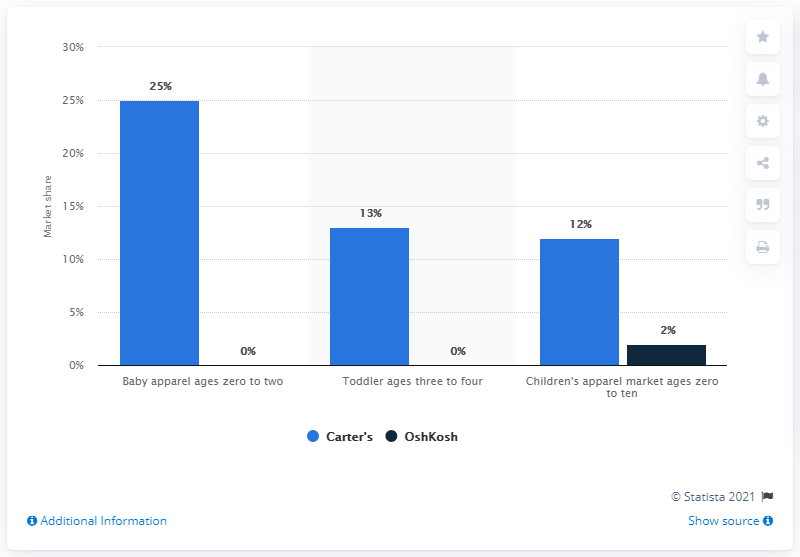Add Carter's percentage in Toddler ages three to four and children's apparel market ages zero to ten and subtract it with Carter's baby apparel ages zero to two, what is the answer? Based on the given image, Carter's holds a 13% market share in the Toddler (ages three to four) category and a 12% market share in the Children's apparel market (ages zero to ten). Adding these values gives us 25%. Then, we subtract Carter's market share in the Baby apparel category (ages zero to two), which stands at 25%. Therefore, 25% - 25% results in 0%. So, there is no difference in the combined market share of Toddler and Children's apparel categories compared to the Baby apparel category for Carter's. 